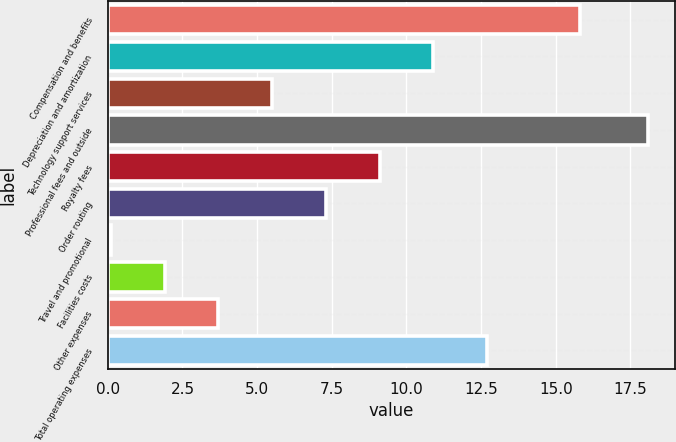Convert chart to OTSL. <chart><loc_0><loc_0><loc_500><loc_500><bar_chart><fcel>Compensation and benefits<fcel>Depreciation and amortization<fcel>Technology support services<fcel>Professional fees and outside<fcel>Royalty fees<fcel>Order routing<fcel>Travel and promotional<fcel>Facilities costs<fcel>Other expenses<fcel>Total operating expenses<nl><fcel>15.8<fcel>10.9<fcel>5.5<fcel>18.1<fcel>9.1<fcel>7.3<fcel>0.1<fcel>1.9<fcel>3.7<fcel>12.7<nl></chart> 